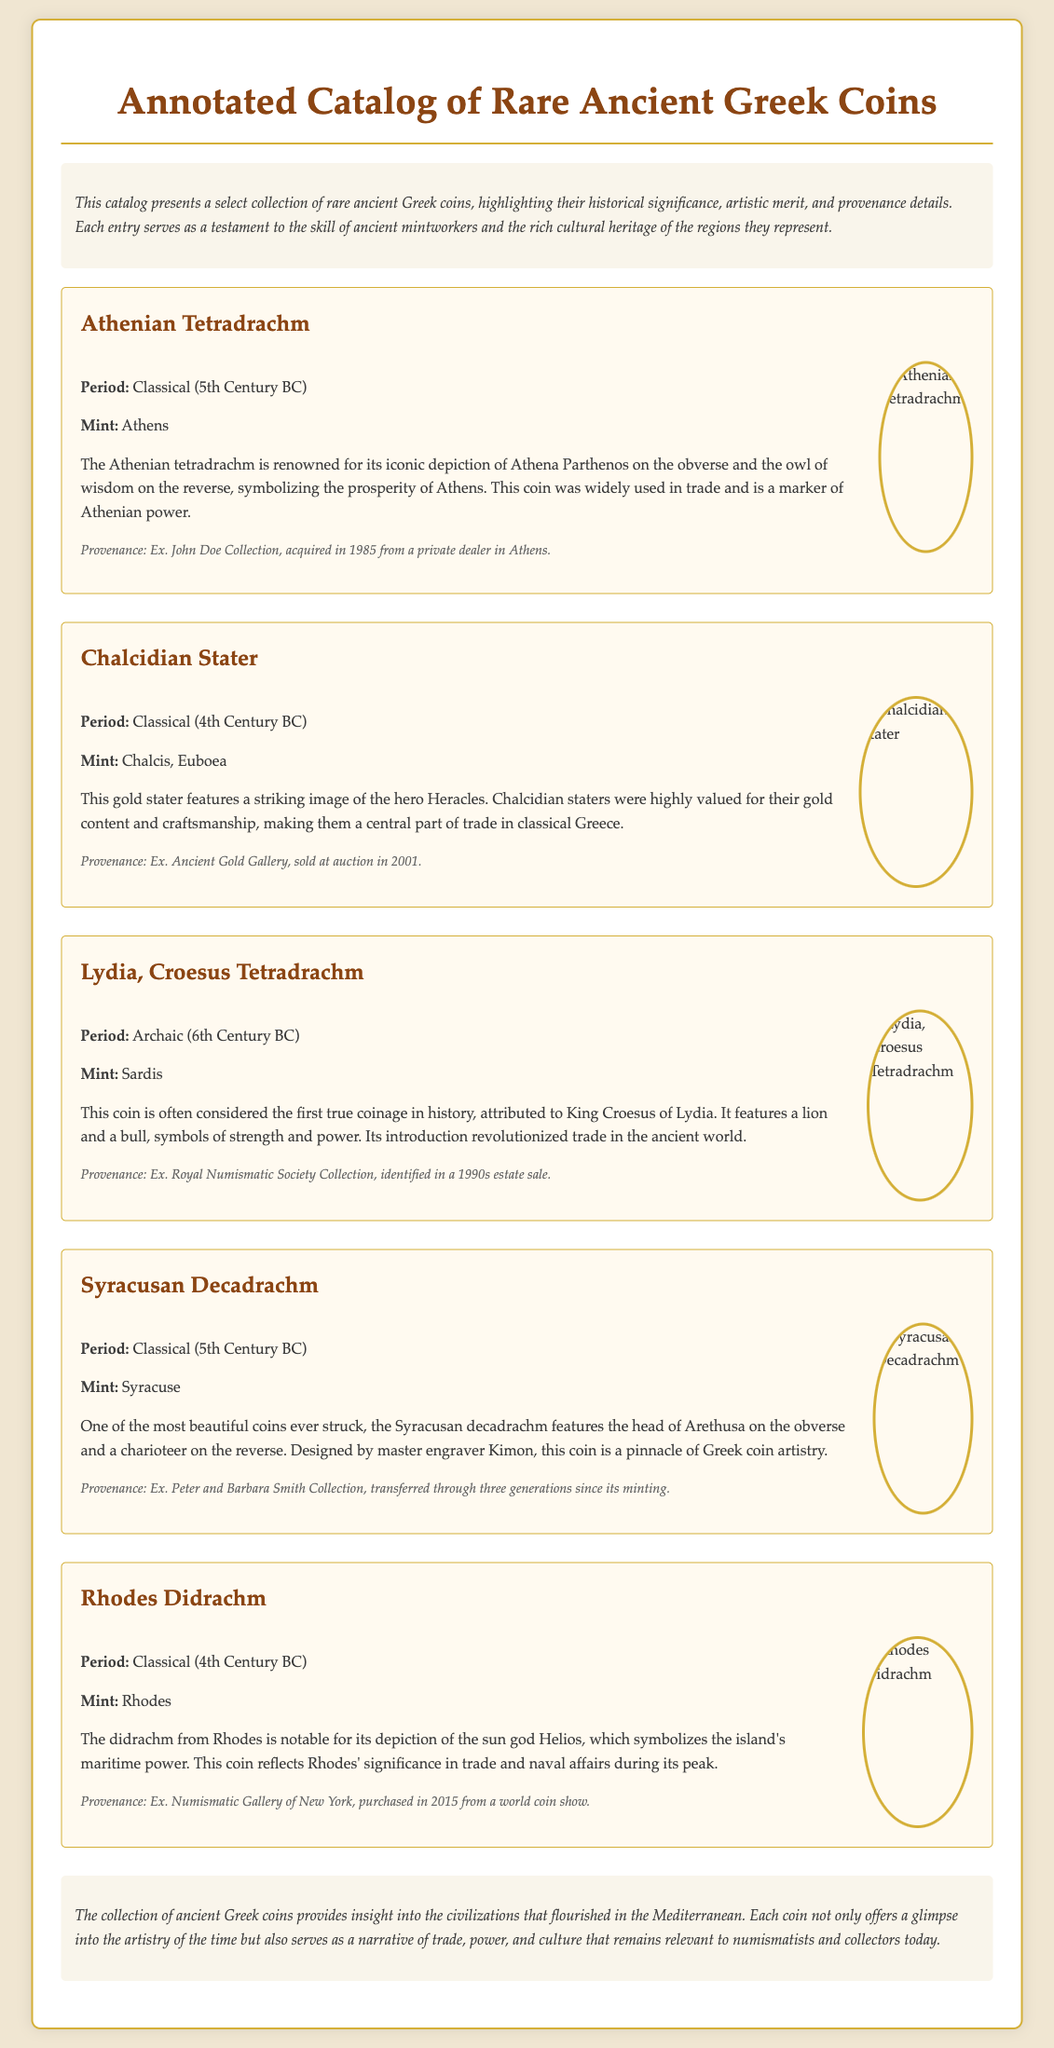What is the title of the document? The title appears prominently at the beginning and is “Annotated Catalog of Rare Ancient Greek Coins.”
Answer: Annotated Catalog of Rare Ancient Greek Coins How many coins are featured in the catalog? There are five entries described in the document, each representing a different coin.
Answer: Five What is the period of the Athenian Tetradrachm? The period is mentioned in the details of the coin as “Classical (5th Century BC).”
Answer: Classical (5th Century BC) Who is depicted on the reverse of the Athenian Tetradrachm? The reverse features the “owl of wisdom,” a symbol associated with Athena.
Answer: Owl of wisdom Which mint produced the Chalcidian Stater? The mint mentioned for the Chalcidian Stater is “Chalcis, Euboea.”
Answer: Chalcis, Euboea What significant historical figure is linked to the Lydia, Croesus Tetradrachm? The coin is attributed to “King Croesus of Lydia,” highlighting its historical importance.
Answer: King Croesus of Lydia What is the provenance of the Syracusan Decadrachm? The provenance specified is “Ex. Peter and Barbara Smith Collection, transferred through three generations since its minting.”
Answer: Ex. Peter and Barbara Smith Collection, transferred through three generations since its minting Which coin is noted for featuring the sun god Helios? The coin described with the sun god Helios is the “Rhodes Didrachm.”
Answer: Rhodes Didrachm What aspect of trade does the Athenian Tetradrachm symbolize? The coin symbolizes the “prosperity of Athens,” reflecting its economic power and influence.
Answer: Prosperity of Athens 